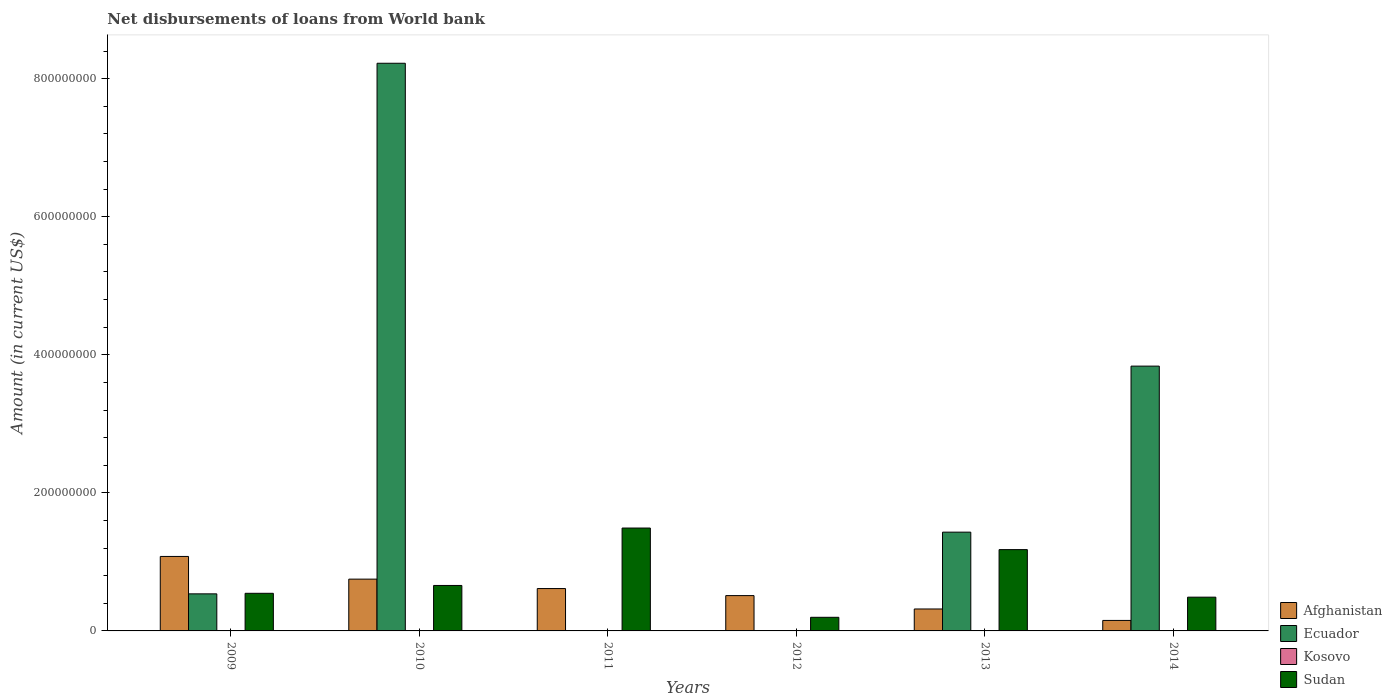How many different coloured bars are there?
Ensure brevity in your answer.  3. How many groups of bars are there?
Your answer should be compact. 6. Are the number of bars per tick equal to the number of legend labels?
Your response must be concise. No. Are the number of bars on each tick of the X-axis equal?
Your response must be concise. No. How many bars are there on the 3rd tick from the left?
Give a very brief answer. 2. How many bars are there on the 3rd tick from the right?
Offer a terse response. 2. What is the amount of loan disbursed from World Bank in Kosovo in 2014?
Give a very brief answer. 0. Across all years, what is the maximum amount of loan disbursed from World Bank in Sudan?
Provide a succinct answer. 1.49e+08. In which year was the amount of loan disbursed from World Bank in Ecuador maximum?
Provide a succinct answer. 2010. What is the total amount of loan disbursed from World Bank in Kosovo in the graph?
Keep it short and to the point. 0. What is the difference between the amount of loan disbursed from World Bank in Afghanistan in 2010 and that in 2011?
Your answer should be compact. 1.37e+07. What is the difference between the amount of loan disbursed from World Bank in Afghanistan in 2010 and the amount of loan disbursed from World Bank in Sudan in 2014?
Provide a short and direct response. 2.61e+07. What is the average amount of loan disbursed from World Bank in Sudan per year?
Make the answer very short. 7.60e+07. In the year 2009, what is the difference between the amount of loan disbursed from World Bank in Ecuador and amount of loan disbursed from World Bank in Afghanistan?
Make the answer very short. -5.42e+07. In how many years, is the amount of loan disbursed from World Bank in Kosovo greater than 120000000 US$?
Keep it short and to the point. 0. What is the ratio of the amount of loan disbursed from World Bank in Sudan in 2012 to that in 2013?
Your answer should be compact. 0.17. Is the difference between the amount of loan disbursed from World Bank in Ecuador in 2013 and 2014 greater than the difference between the amount of loan disbursed from World Bank in Afghanistan in 2013 and 2014?
Offer a terse response. No. What is the difference between the highest and the second highest amount of loan disbursed from World Bank in Ecuador?
Your answer should be compact. 4.39e+08. What is the difference between the highest and the lowest amount of loan disbursed from World Bank in Ecuador?
Keep it short and to the point. 8.22e+08. In how many years, is the amount of loan disbursed from World Bank in Kosovo greater than the average amount of loan disbursed from World Bank in Kosovo taken over all years?
Offer a very short reply. 0. Is it the case that in every year, the sum of the amount of loan disbursed from World Bank in Ecuador and amount of loan disbursed from World Bank in Kosovo is greater than the amount of loan disbursed from World Bank in Afghanistan?
Provide a short and direct response. No. What is the difference between two consecutive major ticks on the Y-axis?
Your response must be concise. 2.00e+08. Are the values on the major ticks of Y-axis written in scientific E-notation?
Make the answer very short. No. What is the title of the graph?
Offer a terse response. Net disbursements of loans from World bank. Does "Cote d'Ivoire" appear as one of the legend labels in the graph?
Your response must be concise. No. What is the label or title of the Y-axis?
Your answer should be compact. Amount (in current US$). What is the Amount (in current US$) in Afghanistan in 2009?
Provide a succinct answer. 1.08e+08. What is the Amount (in current US$) of Ecuador in 2009?
Give a very brief answer. 5.37e+07. What is the Amount (in current US$) in Kosovo in 2009?
Provide a short and direct response. 0. What is the Amount (in current US$) of Sudan in 2009?
Ensure brevity in your answer.  5.45e+07. What is the Amount (in current US$) in Afghanistan in 2010?
Give a very brief answer. 7.50e+07. What is the Amount (in current US$) in Ecuador in 2010?
Provide a short and direct response. 8.22e+08. What is the Amount (in current US$) in Kosovo in 2010?
Your answer should be compact. 0. What is the Amount (in current US$) of Sudan in 2010?
Offer a terse response. 6.59e+07. What is the Amount (in current US$) in Afghanistan in 2011?
Your answer should be very brief. 6.14e+07. What is the Amount (in current US$) of Ecuador in 2011?
Provide a short and direct response. 0. What is the Amount (in current US$) in Sudan in 2011?
Offer a terse response. 1.49e+08. What is the Amount (in current US$) in Afghanistan in 2012?
Make the answer very short. 5.12e+07. What is the Amount (in current US$) in Kosovo in 2012?
Ensure brevity in your answer.  0. What is the Amount (in current US$) of Sudan in 2012?
Give a very brief answer. 1.97e+07. What is the Amount (in current US$) of Afghanistan in 2013?
Give a very brief answer. 3.18e+07. What is the Amount (in current US$) of Ecuador in 2013?
Give a very brief answer. 1.43e+08. What is the Amount (in current US$) of Kosovo in 2013?
Your response must be concise. 0. What is the Amount (in current US$) of Sudan in 2013?
Offer a very short reply. 1.18e+08. What is the Amount (in current US$) in Afghanistan in 2014?
Ensure brevity in your answer.  1.52e+07. What is the Amount (in current US$) in Ecuador in 2014?
Your answer should be compact. 3.84e+08. What is the Amount (in current US$) of Kosovo in 2014?
Your response must be concise. 0. What is the Amount (in current US$) in Sudan in 2014?
Your answer should be compact. 4.89e+07. Across all years, what is the maximum Amount (in current US$) in Afghanistan?
Your answer should be compact. 1.08e+08. Across all years, what is the maximum Amount (in current US$) of Ecuador?
Give a very brief answer. 8.22e+08. Across all years, what is the maximum Amount (in current US$) in Sudan?
Your response must be concise. 1.49e+08. Across all years, what is the minimum Amount (in current US$) in Afghanistan?
Your answer should be very brief. 1.52e+07. Across all years, what is the minimum Amount (in current US$) in Sudan?
Provide a short and direct response. 1.97e+07. What is the total Amount (in current US$) in Afghanistan in the graph?
Give a very brief answer. 3.42e+08. What is the total Amount (in current US$) in Ecuador in the graph?
Make the answer very short. 1.40e+09. What is the total Amount (in current US$) in Kosovo in the graph?
Keep it short and to the point. 0. What is the total Amount (in current US$) in Sudan in the graph?
Your response must be concise. 4.56e+08. What is the difference between the Amount (in current US$) in Afghanistan in 2009 and that in 2010?
Your answer should be very brief. 3.29e+07. What is the difference between the Amount (in current US$) of Ecuador in 2009 and that in 2010?
Provide a succinct answer. -7.69e+08. What is the difference between the Amount (in current US$) in Sudan in 2009 and that in 2010?
Keep it short and to the point. -1.14e+07. What is the difference between the Amount (in current US$) of Afghanistan in 2009 and that in 2011?
Offer a very short reply. 4.65e+07. What is the difference between the Amount (in current US$) of Sudan in 2009 and that in 2011?
Give a very brief answer. -9.45e+07. What is the difference between the Amount (in current US$) of Afghanistan in 2009 and that in 2012?
Keep it short and to the point. 5.67e+07. What is the difference between the Amount (in current US$) in Sudan in 2009 and that in 2012?
Your answer should be very brief. 3.48e+07. What is the difference between the Amount (in current US$) of Afghanistan in 2009 and that in 2013?
Keep it short and to the point. 7.61e+07. What is the difference between the Amount (in current US$) of Ecuador in 2009 and that in 2013?
Provide a short and direct response. -8.94e+07. What is the difference between the Amount (in current US$) in Sudan in 2009 and that in 2013?
Ensure brevity in your answer.  -6.33e+07. What is the difference between the Amount (in current US$) of Afghanistan in 2009 and that in 2014?
Make the answer very short. 9.27e+07. What is the difference between the Amount (in current US$) in Ecuador in 2009 and that in 2014?
Your response must be concise. -3.30e+08. What is the difference between the Amount (in current US$) in Sudan in 2009 and that in 2014?
Offer a very short reply. 5.61e+06. What is the difference between the Amount (in current US$) of Afghanistan in 2010 and that in 2011?
Offer a very short reply. 1.37e+07. What is the difference between the Amount (in current US$) in Sudan in 2010 and that in 2011?
Offer a very short reply. -8.32e+07. What is the difference between the Amount (in current US$) of Afghanistan in 2010 and that in 2012?
Your answer should be very brief. 2.39e+07. What is the difference between the Amount (in current US$) of Sudan in 2010 and that in 2012?
Give a very brief answer. 4.61e+07. What is the difference between the Amount (in current US$) of Afghanistan in 2010 and that in 2013?
Provide a short and direct response. 4.33e+07. What is the difference between the Amount (in current US$) of Ecuador in 2010 and that in 2013?
Offer a terse response. 6.79e+08. What is the difference between the Amount (in current US$) of Sudan in 2010 and that in 2013?
Your answer should be compact. -5.19e+07. What is the difference between the Amount (in current US$) in Afghanistan in 2010 and that in 2014?
Make the answer very short. 5.98e+07. What is the difference between the Amount (in current US$) of Ecuador in 2010 and that in 2014?
Make the answer very short. 4.39e+08. What is the difference between the Amount (in current US$) in Sudan in 2010 and that in 2014?
Keep it short and to the point. 1.70e+07. What is the difference between the Amount (in current US$) in Afghanistan in 2011 and that in 2012?
Keep it short and to the point. 1.02e+07. What is the difference between the Amount (in current US$) of Sudan in 2011 and that in 2012?
Provide a short and direct response. 1.29e+08. What is the difference between the Amount (in current US$) of Afghanistan in 2011 and that in 2013?
Make the answer very short. 2.96e+07. What is the difference between the Amount (in current US$) in Sudan in 2011 and that in 2013?
Provide a short and direct response. 3.12e+07. What is the difference between the Amount (in current US$) of Afghanistan in 2011 and that in 2014?
Offer a very short reply. 4.62e+07. What is the difference between the Amount (in current US$) in Sudan in 2011 and that in 2014?
Your response must be concise. 1.00e+08. What is the difference between the Amount (in current US$) in Afghanistan in 2012 and that in 2013?
Give a very brief answer. 1.94e+07. What is the difference between the Amount (in current US$) of Sudan in 2012 and that in 2013?
Provide a short and direct response. -9.81e+07. What is the difference between the Amount (in current US$) of Afghanistan in 2012 and that in 2014?
Keep it short and to the point. 3.60e+07. What is the difference between the Amount (in current US$) of Sudan in 2012 and that in 2014?
Offer a terse response. -2.92e+07. What is the difference between the Amount (in current US$) of Afghanistan in 2013 and that in 2014?
Ensure brevity in your answer.  1.66e+07. What is the difference between the Amount (in current US$) of Ecuador in 2013 and that in 2014?
Ensure brevity in your answer.  -2.41e+08. What is the difference between the Amount (in current US$) of Sudan in 2013 and that in 2014?
Give a very brief answer. 6.89e+07. What is the difference between the Amount (in current US$) of Afghanistan in 2009 and the Amount (in current US$) of Ecuador in 2010?
Keep it short and to the point. -7.14e+08. What is the difference between the Amount (in current US$) in Afghanistan in 2009 and the Amount (in current US$) in Sudan in 2010?
Keep it short and to the point. 4.20e+07. What is the difference between the Amount (in current US$) of Ecuador in 2009 and the Amount (in current US$) of Sudan in 2010?
Your response must be concise. -1.22e+07. What is the difference between the Amount (in current US$) in Afghanistan in 2009 and the Amount (in current US$) in Sudan in 2011?
Provide a succinct answer. -4.12e+07. What is the difference between the Amount (in current US$) of Ecuador in 2009 and the Amount (in current US$) of Sudan in 2011?
Your answer should be very brief. -9.53e+07. What is the difference between the Amount (in current US$) of Afghanistan in 2009 and the Amount (in current US$) of Sudan in 2012?
Offer a terse response. 8.82e+07. What is the difference between the Amount (in current US$) of Ecuador in 2009 and the Amount (in current US$) of Sudan in 2012?
Keep it short and to the point. 3.40e+07. What is the difference between the Amount (in current US$) of Afghanistan in 2009 and the Amount (in current US$) of Ecuador in 2013?
Your response must be concise. -3.52e+07. What is the difference between the Amount (in current US$) of Afghanistan in 2009 and the Amount (in current US$) of Sudan in 2013?
Ensure brevity in your answer.  -9.90e+06. What is the difference between the Amount (in current US$) of Ecuador in 2009 and the Amount (in current US$) of Sudan in 2013?
Provide a succinct answer. -6.41e+07. What is the difference between the Amount (in current US$) in Afghanistan in 2009 and the Amount (in current US$) in Ecuador in 2014?
Provide a succinct answer. -2.76e+08. What is the difference between the Amount (in current US$) in Afghanistan in 2009 and the Amount (in current US$) in Sudan in 2014?
Ensure brevity in your answer.  5.90e+07. What is the difference between the Amount (in current US$) in Ecuador in 2009 and the Amount (in current US$) in Sudan in 2014?
Give a very brief answer. 4.80e+06. What is the difference between the Amount (in current US$) of Afghanistan in 2010 and the Amount (in current US$) of Sudan in 2011?
Provide a succinct answer. -7.40e+07. What is the difference between the Amount (in current US$) of Ecuador in 2010 and the Amount (in current US$) of Sudan in 2011?
Your response must be concise. 6.73e+08. What is the difference between the Amount (in current US$) of Afghanistan in 2010 and the Amount (in current US$) of Sudan in 2012?
Your answer should be very brief. 5.53e+07. What is the difference between the Amount (in current US$) in Ecuador in 2010 and the Amount (in current US$) in Sudan in 2012?
Offer a terse response. 8.03e+08. What is the difference between the Amount (in current US$) of Afghanistan in 2010 and the Amount (in current US$) of Ecuador in 2013?
Provide a short and direct response. -6.80e+07. What is the difference between the Amount (in current US$) in Afghanistan in 2010 and the Amount (in current US$) in Sudan in 2013?
Provide a short and direct response. -4.28e+07. What is the difference between the Amount (in current US$) in Ecuador in 2010 and the Amount (in current US$) in Sudan in 2013?
Keep it short and to the point. 7.05e+08. What is the difference between the Amount (in current US$) of Afghanistan in 2010 and the Amount (in current US$) of Ecuador in 2014?
Your response must be concise. -3.09e+08. What is the difference between the Amount (in current US$) in Afghanistan in 2010 and the Amount (in current US$) in Sudan in 2014?
Make the answer very short. 2.61e+07. What is the difference between the Amount (in current US$) in Ecuador in 2010 and the Amount (in current US$) in Sudan in 2014?
Make the answer very short. 7.73e+08. What is the difference between the Amount (in current US$) of Afghanistan in 2011 and the Amount (in current US$) of Sudan in 2012?
Ensure brevity in your answer.  4.16e+07. What is the difference between the Amount (in current US$) in Afghanistan in 2011 and the Amount (in current US$) in Ecuador in 2013?
Your answer should be compact. -8.17e+07. What is the difference between the Amount (in current US$) in Afghanistan in 2011 and the Amount (in current US$) in Sudan in 2013?
Ensure brevity in your answer.  -5.64e+07. What is the difference between the Amount (in current US$) in Afghanistan in 2011 and the Amount (in current US$) in Ecuador in 2014?
Make the answer very short. -3.22e+08. What is the difference between the Amount (in current US$) in Afghanistan in 2011 and the Amount (in current US$) in Sudan in 2014?
Keep it short and to the point. 1.25e+07. What is the difference between the Amount (in current US$) of Afghanistan in 2012 and the Amount (in current US$) of Ecuador in 2013?
Provide a short and direct response. -9.19e+07. What is the difference between the Amount (in current US$) in Afghanistan in 2012 and the Amount (in current US$) in Sudan in 2013?
Keep it short and to the point. -6.66e+07. What is the difference between the Amount (in current US$) of Afghanistan in 2012 and the Amount (in current US$) of Ecuador in 2014?
Make the answer very short. -3.32e+08. What is the difference between the Amount (in current US$) of Afghanistan in 2012 and the Amount (in current US$) of Sudan in 2014?
Offer a very short reply. 2.26e+06. What is the difference between the Amount (in current US$) in Afghanistan in 2013 and the Amount (in current US$) in Ecuador in 2014?
Your response must be concise. -3.52e+08. What is the difference between the Amount (in current US$) in Afghanistan in 2013 and the Amount (in current US$) in Sudan in 2014?
Offer a terse response. -1.71e+07. What is the difference between the Amount (in current US$) of Ecuador in 2013 and the Amount (in current US$) of Sudan in 2014?
Your answer should be compact. 9.42e+07. What is the average Amount (in current US$) of Afghanistan per year?
Your answer should be compact. 5.71e+07. What is the average Amount (in current US$) in Ecuador per year?
Make the answer very short. 2.34e+08. What is the average Amount (in current US$) in Sudan per year?
Provide a short and direct response. 7.60e+07. In the year 2009, what is the difference between the Amount (in current US$) in Afghanistan and Amount (in current US$) in Ecuador?
Your answer should be compact. 5.42e+07. In the year 2009, what is the difference between the Amount (in current US$) of Afghanistan and Amount (in current US$) of Sudan?
Make the answer very short. 5.34e+07. In the year 2009, what is the difference between the Amount (in current US$) in Ecuador and Amount (in current US$) in Sudan?
Give a very brief answer. -8.03e+05. In the year 2010, what is the difference between the Amount (in current US$) in Afghanistan and Amount (in current US$) in Ecuador?
Provide a succinct answer. -7.47e+08. In the year 2010, what is the difference between the Amount (in current US$) of Afghanistan and Amount (in current US$) of Sudan?
Provide a short and direct response. 9.18e+06. In the year 2010, what is the difference between the Amount (in current US$) in Ecuador and Amount (in current US$) in Sudan?
Make the answer very short. 7.57e+08. In the year 2011, what is the difference between the Amount (in current US$) of Afghanistan and Amount (in current US$) of Sudan?
Your answer should be very brief. -8.77e+07. In the year 2012, what is the difference between the Amount (in current US$) of Afghanistan and Amount (in current US$) of Sudan?
Give a very brief answer. 3.14e+07. In the year 2013, what is the difference between the Amount (in current US$) in Afghanistan and Amount (in current US$) in Ecuador?
Your response must be concise. -1.11e+08. In the year 2013, what is the difference between the Amount (in current US$) of Afghanistan and Amount (in current US$) of Sudan?
Ensure brevity in your answer.  -8.60e+07. In the year 2013, what is the difference between the Amount (in current US$) of Ecuador and Amount (in current US$) of Sudan?
Offer a terse response. 2.53e+07. In the year 2014, what is the difference between the Amount (in current US$) in Afghanistan and Amount (in current US$) in Ecuador?
Your answer should be very brief. -3.68e+08. In the year 2014, what is the difference between the Amount (in current US$) of Afghanistan and Amount (in current US$) of Sudan?
Offer a terse response. -3.37e+07. In the year 2014, what is the difference between the Amount (in current US$) of Ecuador and Amount (in current US$) of Sudan?
Your answer should be compact. 3.35e+08. What is the ratio of the Amount (in current US$) in Afghanistan in 2009 to that in 2010?
Offer a terse response. 1.44. What is the ratio of the Amount (in current US$) in Ecuador in 2009 to that in 2010?
Provide a succinct answer. 0.07. What is the ratio of the Amount (in current US$) in Sudan in 2009 to that in 2010?
Keep it short and to the point. 0.83. What is the ratio of the Amount (in current US$) of Afghanistan in 2009 to that in 2011?
Make the answer very short. 1.76. What is the ratio of the Amount (in current US$) of Sudan in 2009 to that in 2011?
Keep it short and to the point. 0.37. What is the ratio of the Amount (in current US$) of Afghanistan in 2009 to that in 2012?
Provide a succinct answer. 2.11. What is the ratio of the Amount (in current US$) of Sudan in 2009 to that in 2012?
Your answer should be compact. 2.76. What is the ratio of the Amount (in current US$) in Afghanistan in 2009 to that in 2013?
Ensure brevity in your answer.  3.39. What is the ratio of the Amount (in current US$) of Ecuador in 2009 to that in 2013?
Your answer should be compact. 0.38. What is the ratio of the Amount (in current US$) in Sudan in 2009 to that in 2013?
Provide a succinct answer. 0.46. What is the ratio of the Amount (in current US$) in Afghanistan in 2009 to that in 2014?
Offer a terse response. 7.1. What is the ratio of the Amount (in current US$) of Ecuador in 2009 to that in 2014?
Offer a very short reply. 0.14. What is the ratio of the Amount (in current US$) of Sudan in 2009 to that in 2014?
Keep it short and to the point. 1.11. What is the ratio of the Amount (in current US$) of Afghanistan in 2010 to that in 2011?
Give a very brief answer. 1.22. What is the ratio of the Amount (in current US$) in Sudan in 2010 to that in 2011?
Give a very brief answer. 0.44. What is the ratio of the Amount (in current US$) of Afghanistan in 2010 to that in 2012?
Ensure brevity in your answer.  1.47. What is the ratio of the Amount (in current US$) of Sudan in 2010 to that in 2012?
Provide a succinct answer. 3.34. What is the ratio of the Amount (in current US$) of Afghanistan in 2010 to that in 2013?
Keep it short and to the point. 2.36. What is the ratio of the Amount (in current US$) of Ecuador in 2010 to that in 2013?
Ensure brevity in your answer.  5.75. What is the ratio of the Amount (in current US$) of Sudan in 2010 to that in 2013?
Ensure brevity in your answer.  0.56. What is the ratio of the Amount (in current US$) in Afghanistan in 2010 to that in 2014?
Keep it short and to the point. 4.94. What is the ratio of the Amount (in current US$) of Ecuador in 2010 to that in 2014?
Make the answer very short. 2.14. What is the ratio of the Amount (in current US$) of Sudan in 2010 to that in 2014?
Make the answer very short. 1.35. What is the ratio of the Amount (in current US$) of Afghanistan in 2011 to that in 2012?
Offer a terse response. 1.2. What is the ratio of the Amount (in current US$) of Sudan in 2011 to that in 2012?
Provide a succinct answer. 7.55. What is the ratio of the Amount (in current US$) in Afghanistan in 2011 to that in 2013?
Offer a terse response. 1.93. What is the ratio of the Amount (in current US$) of Sudan in 2011 to that in 2013?
Provide a succinct answer. 1.27. What is the ratio of the Amount (in current US$) of Afghanistan in 2011 to that in 2014?
Your response must be concise. 4.04. What is the ratio of the Amount (in current US$) in Sudan in 2011 to that in 2014?
Offer a terse response. 3.05. What is the ratio of the Amount (in current US$) of Afghanistan in 2012 to that in 2013?
Offer a terse response. 1.61. What is the ratio of the Amount (in current US$) of Sudan in 2012 to that in 2013?
Provide a succinct answer. 0.17. What is the ratio of the Amount (in current US$) in Afghanistan in 2012 to that in 2014?
Offer a terse response. 3.37. What is the ratio of the Amount (in current US$) of Sudan in 2012 to that in 2014?
Provide a short and direct response. 0.4. What is the ratio of the Amount (in current US$) in Afghanistan in 2013 to that in 2014?
Offer a very short reply. 2.09. What is the ratio of the Amount (in current US$) in Ecuador in 2013 to that in 2014?
Your response must be concise. 0.37. What is the ratio of the Amount (in current US$) in Sudan in 2013 to that in 2014?
Your answer should be compact. 2.41. What is the difference between the highest and the second highest Amount (in current US$) in Afghanistan?
Give a very brief answer. 3.29e+07. What is the difference between the highest and the second highest Amount (in current US$) of Ecuador?
Give a very brief answer. 4.39e+08. What is the difference between the highest and the second highest Amount (in current US$) of Sudan?
Provide a short and direct response. 3.12e+07. What is the difference between the highest and the lowest Amount (in current US$) of Afghanistan?
Your answer should be very brief. 9.27e+07. What is the difference between the highest and the lowest Amount (in current US$) of Ecuador?
Provide a succinct answer. 8.22e+08. What is the difference between the highest and the lowest Amount (in current US$) in Sudan?
Your response must be concise. 1.29e+08. 